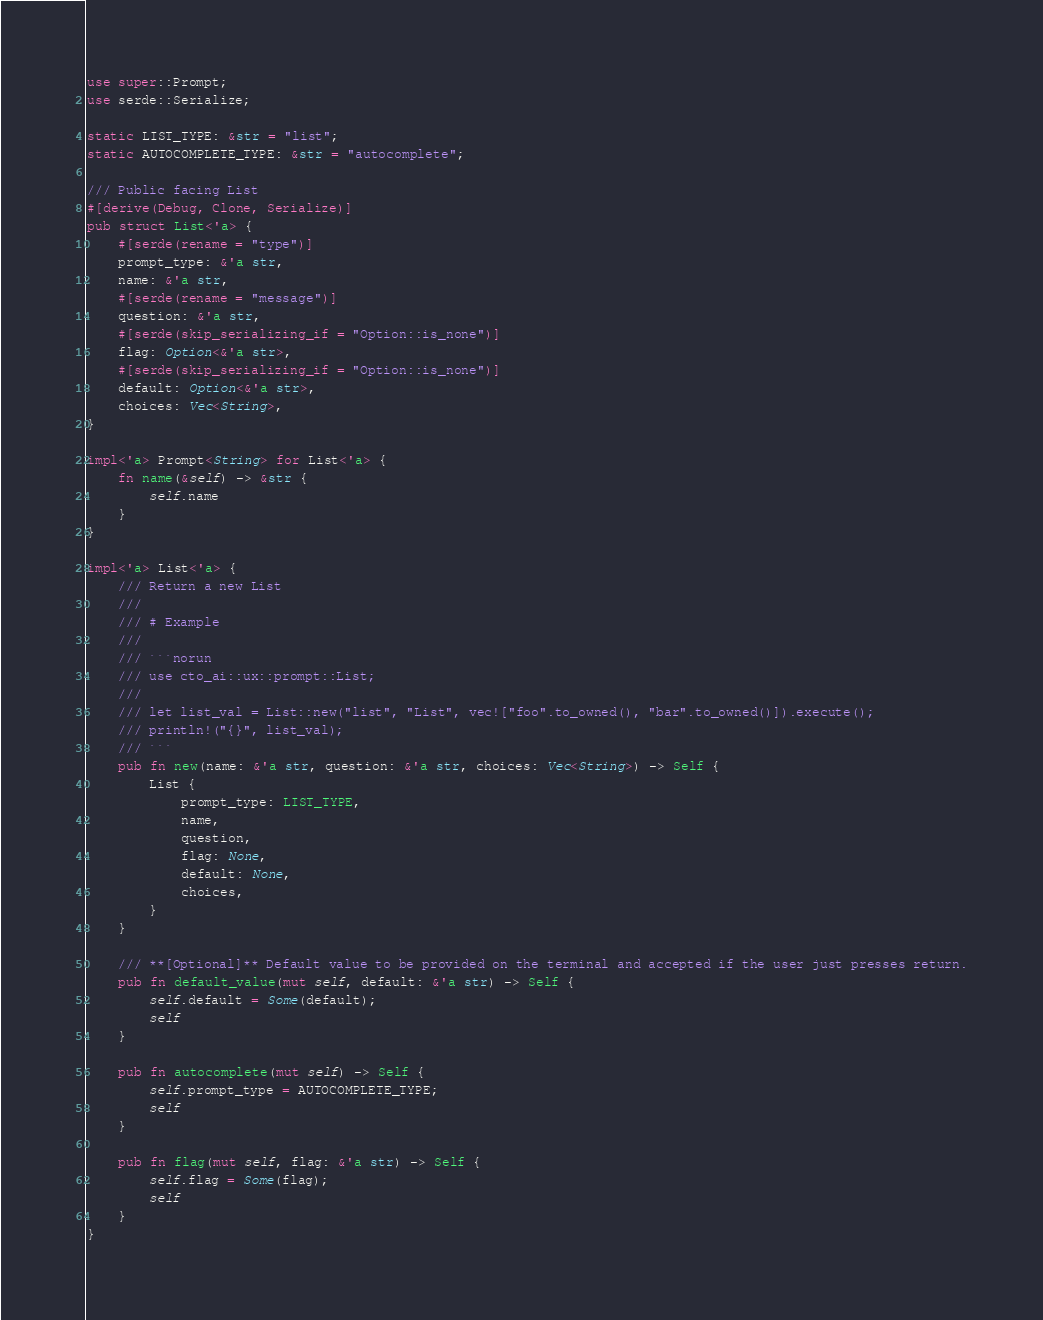Convert code to text. <code><loc_0><loc_0><loc_500><loc_500><_Rust_>use super::Prompt;
use serde::Serialize;

static LIST_TYPE: &str = "list";
static AUTOCOMPLETE_TYPE: &str = "autocomplete";

/// Public facing List
#[derive(Debug, Clone, Serialize)]
pub struct List<'a> {
    #[serde(rename = "type")]
    prompt_type: &'a str,
    name: &'a str,
    #[serde(rename = "message")]
    question: &'a str,
    #[serde(skip_serializing_if = "Option::is_none")]
    flag: Option<&'a str>,
    #[serde(skip_serializing_if = "Option::is_none")]
    default: Option<&'a str>,
    choices: Vec<String>,
}

impl<'a> Prompt<String> for List<'a> {
    fn name(&self) -> &str {
        self.name
    }
}

impl<'a> List<'a> {
    /// Return a new List
    ///
    /// # Example
    ///
    /// ```norun
    /// use cto_ai::ux::prompt::List;
    ///
    /// let list_val = List::new("list", "List", vec!["foo".to_owned(), "bar".to_owned()]).execute();
    /// println!("{}", list_val);
    /// ```
    pub fn new(name: &'a str, question: &'a str, choices: Vec<String>) -> Self {
        List {
            prompt_type: LIST_TYPE,
            name,
            question,
            flag: None,
            default: None,
            choices,
        }
    }

    /// **[Optional]** Default value to be provided on the terminal and accepted if the user just presses return.
    pub fn default_value(mut self, default: &'a str) -> Self {
        self.default = Some(default);
        self
    }

    pub fn autocomplete(mut self) -> Self {
        self.prompt_type = AUTOCOMPLETE_TYPE;
        self
    }

    pub fn flag(mut self, flag: &'a str) -> Self {
        self.flag = Some(flag);
        self
    }
}
</code> 